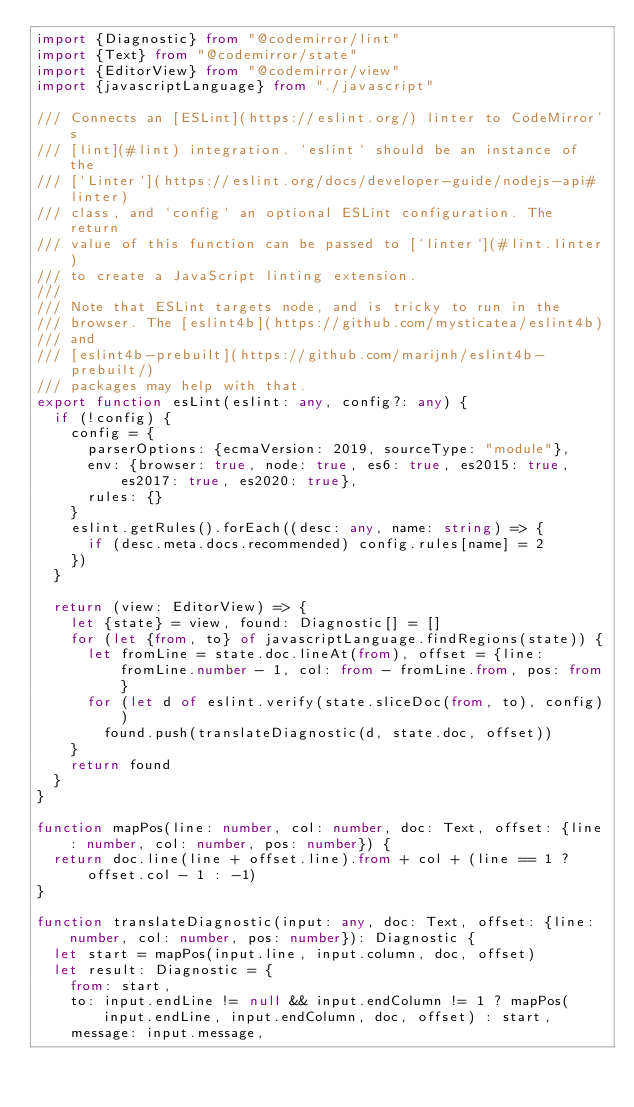<code> <loc_0><loc_0><loc_500><loc_500><_TypeScript_>import {Diagnostic} from "@codemirror/lint"
import {Text} from "@codemirror/state"
import {EditorView} from "@codemirror/view"
import {javascriptLanguage} from "./javascript"

/// Connects an [ESLint](https://eslint.org/) linter to CodeMirror's
/// [lint](#lint) integration. `eslint` should be an instance of the
/// [`Linter`](https://eslint.org/docs/developer-guide/nodejs-api#linter)
/// class, and `config` an optional ESLint configuration. The return
/// value of this function can be passed to [`linter`](#lint.linter)
/// to create a JavaScript linting extension.
///
/// Note that ESLint targets node, and is tricky to run in the
/// browser. The [eslint4b](https://github.com/mysticatea/eslint4b)
/// and
/// [eslint4b-prebuilt](https://github.com/marijnh/eslint4b-prebuilt/)
/// packages may help with that.
export function esLint(eslint: any, config?: any) {
  if (!config) {
    config = {
      parserOptions: {ecmaVersion: 2019, sourceType: "module"},
      env: {browser: true, node: true, es6: true, es2015: true, es2017: true, es2020: true},
      rules: {}
    }
    eslint.getRules().forEach((desc: any, name: string) => {
      if (desc.meta.docs.recommended) config.rules[name] = 2
    })
  }

  return (view: EditorView) => {
    let {state} = view, found: Diagnostic[] = []
    for (let {from, to} of javascriptLanguage.findRegions(state)) {
      let fromLine = state.doc.lineAt(from), offset = {line: fromLine.number - 1, col: from - fromLine.from, pos: from}
      for (let d of eslint.verify(state.sliceDoc(from, to), config))
        found.push(translateDiagnostic(d, state.doc, offset))
    }
    return found
  }
}

function mapPos(line: number, col: number, doc: Text, offset: {line: number, col: number, pos: number}) {
  return doc.line(line + offset.line).from + col + (line == 1 ? offset.col - 1 : -1)
}

function translateDiagnostic(input: any, doc: Text, offset: {line: number, col: number, pos: number}): Diagnostic {
  let start = mapPos(input.line, input.column, doc, offset)
  let result: Diagnostic = {
    from: start,
    to: input.endLine != null && input.endColumn != 1 ? mapPos(input.endLine, input.endColumn, doc, offset) : start,
    message: input.message,</code> 